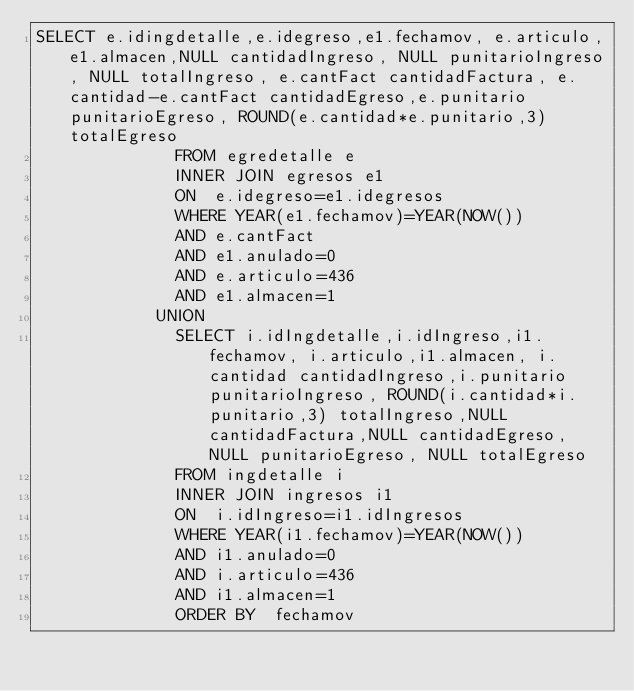<code> <loc_0><loc_0><loc_500><loc_500><_SQL_>SELECT e.idingdetalle,e.idegreso,e1.fechamov, e.articulo,e1.almacen,NULL cantidadIngreso, NULL punitarioIngreso, NULL totalIngreso, e.cantFact cantidadFactura, e.cantidad-e.cantFact cantidadEgreso,e.punitario punitarioEgreso, ROUND(e.cantidad*e.punitario,3) totalEgreso
              FROM egredetalle e
              INNER JOIN egresos e1
              ON  e.idegreso=e1.idegresos
              WHERE YEAR(e1.fechamov)=YEAR(NOW())
              AND e.cantFact
              AND e1.anulado=0
              AND e.articulo=436
              AND e1.almacen=1
            UNION
              SELECT i.idIngdetalle,i.idIngreso,i1.fechamov, i.articulo,i1.almacen, i.cantidad cantidadIngreso,i.punitario punitarioIngreso, ROUND(i.cantidad*i.punitario,3) totalIngreso,NULL cantidadFactura,NULL cantidadEgreso, NULL punitarioEgreso, NULL totalEgreso
              FROM ingdetalle i
              INNER JOIN ingresos i1 
              ON  i.idIngreso=i1.idIngresos
              WHERE YEAR(i1.fechamov)=YEAR(NOW())              
              AND i1.anulado=0
              AND i.articulo=436
              AND i1.almacen=1
              ORDER BY  fechamov</code> 